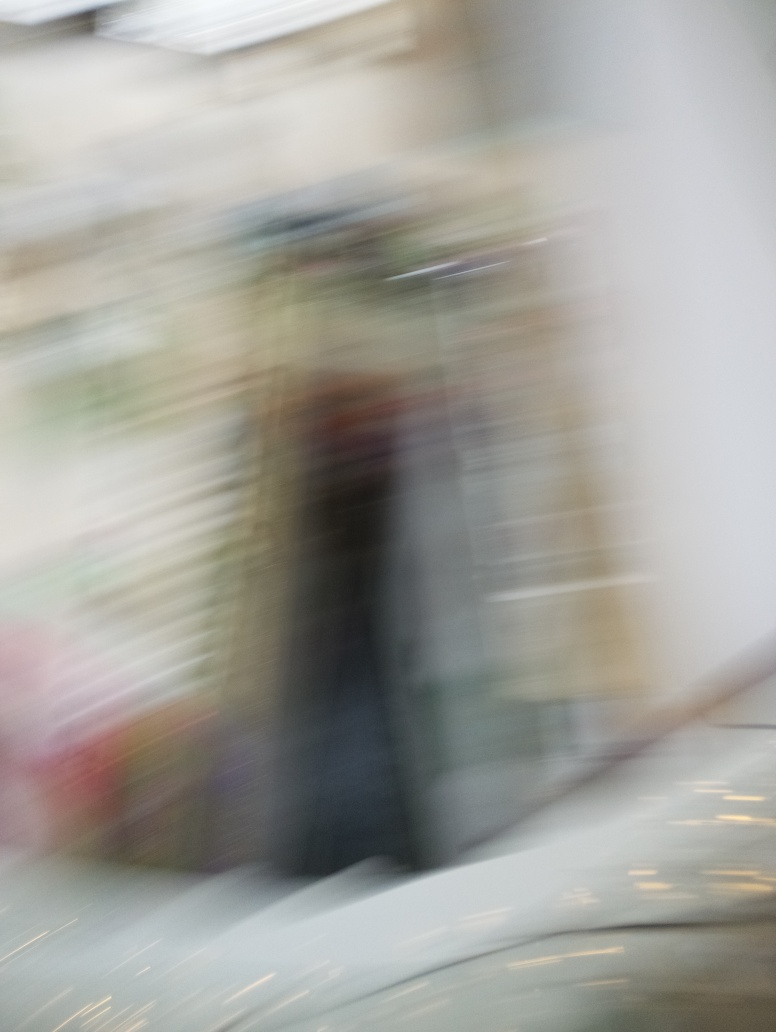Is there anything in the image that indicates the direction of the movement causing the blur? The direction of the streaks of light and the elongation of the shapes in the image suggest a vertical movement. If the camera moved upward or downward or the subject was moving in that direction, those actions could create this type of directional blur. 